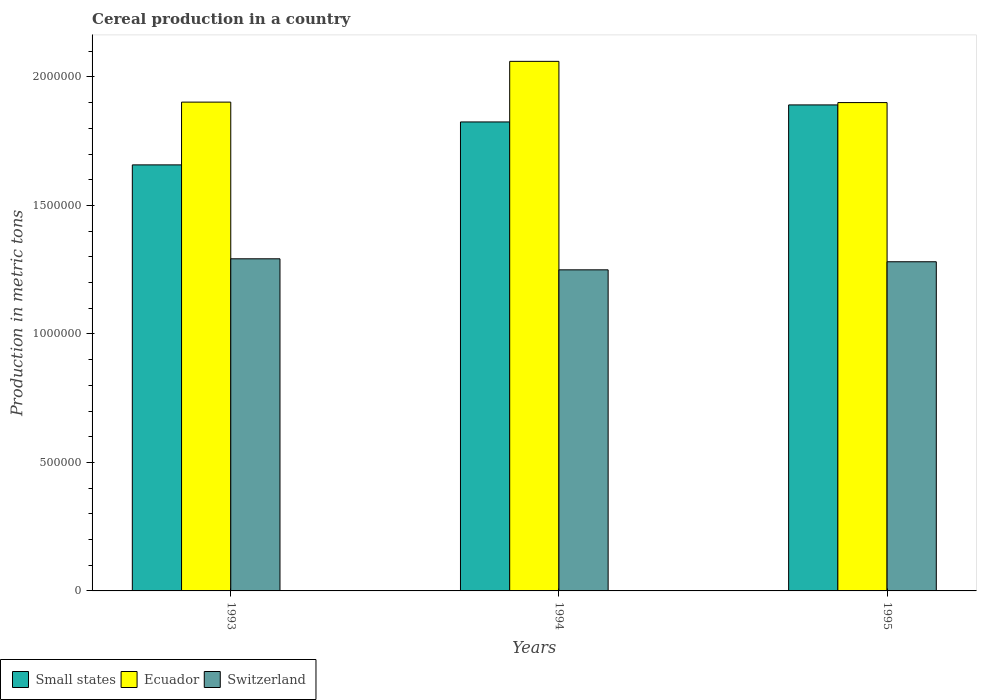How many different coloured bars are there?
Keep it short and to the point. 3. How many groups of bars are there?
Make the answer very short. 3. Are the number of bars per tick equal to the number of legend labels?
Your response must be concise. Yes. How many bars are there on the 1st tick from the left?
Offer a very short reply. 3. How many bars are there on the 2nd tick from the right?
Provide a succinct answer. 3. What is the label of the 1st group of bars from the left?
Your answer should be compact. 1993. In how many cases, is the number of bars for a given year not equal to the number of legend labels?
Keep it short and to the point. 0. What is the total cereal production in Small states in 1994?
Ensure brevity in your answer.  1.82e+06. Across all years, what is the maximum total cereal production in Switzerland?
Ensure brevity in your answer.  1.29e+06. Across all years, what is the minimum total cereal production in Ecuador?
Offer a very short reply. 1.90e+06. In which year was the total cereal production in Small states maximum?
Offer a very short reply. 1995. What is the total total cereal production in Ecuador in the graph?
Offer a terse response. 5.86e+06. What is the difference between the total cereal production in Small states in 1993 and that in 1995?
Keep it short and to the point. -2.33e+05. What is the difference between the total cereal production in Switzerland in 1993 and the total cereal production in Small states in 1994?
Your answer should be compact. -5.33e+05. What is the average total cereal production in Switzerland per year?
Ensure brevity in your answer.  1.27e+06. In the year 1993, what is the difference between the total cereal production in Switzerland and total cereal production in Small states?
Provide a succinct answer. -3.65e+05. What is the ratio of the total cereal production in Ecuador in 1993 to that in 1994?
Give a very brief answer. 0.92. What is the difference between the highest and the second highest total cereal production in Ecuador?
Keep it short and to the point. 1.59e+05. What is the difference between the highest and the lowest total cereal production in Switzerland?
Keep it short and to the point. 4.29e+04. In how many years, is the total cereal production in Ecuador greater than the average total cereal production in Ecuador taken over all years?
Your answer should be very brief. 1. Is the sum of the total cereal production in Ecuador in 1993 and 1995 greater than the maximum total cereal production in Switzerland across all years?
Your answer should be very brief. Yes. What does the 3rd bar from the left in 1995 represents?
Offer a terse response. Switzerland. What does the 1st bar from the right in 1995 represents?
Offer a terse response. Switzerland. What is the difference between two consecutive major ticks on the Y-axis?
Give a very brief answer. 5.00e+05. Are the values on the major ticks of Y-axis written in scientific E-notation?
Offer a very short reply. No. Does the graph contain any zero values?
Make the answer very short. No. Does the graph contain grids?
Provide a succinct answer. No. Where does the legend appear in the graph?
Provide a succinct answer. Bottom left. How many legend labels are there?
Provide a succinct answer. 3. How are the legend labels stacked?
Ensure brevity in your answer.  Horizontal. What is the title of the graph?
Ensure brevity in your answer.  Cereal production in a country. Does "Lebanon" appear as one of the legend labels in the graph?
Your answer should be very brief. No. What is the label or title of the X-axis?
Your answer should be very brief. Years. What is the label or title of the Y-axis?
Your answer should be very brief. Production in metric tons. What is the Production in metric tons of Small states in 1993?
Offer a very short reply. 1.66e+06. What is the Production in metric tons of Ecuador in 1993?
Your answer should be compact. 1.90e+06. What is the Production in metric tons in Switzerland in 1993?
Your answer should be very brief. 1.29e+06. What is the Production in metric tons in Small states in 1994?
Ensure brevity in your answer.  1.82e+06. What is the Production in metric tons of Ecuador in 1994?
Offer a terse response. 2.06e+06. What is the Production in metric tons of Switzerland in 1994?
Your response must be concise. 1.25e+06. What is the Production in metric tons of Small states in 1995?
Keep it short and to the point. 1.89e+06. What is the Production in metric tons of Ecuador in 1995?
Provide a succinct answer. 1.90e+06. What is the Production in metric tons of Switzerland in 1995?
Give a very brief answer. 1.28e+06. Across all years, what is the maximum Production in metric tons in Small states?
Provide a succinct answer. 1.89e+06. Across all years, what is the maximum Production in metric tons of Ecuador?
Make the answer very short. 2.06e+06. Across all years, what is the maximum Production in metric tons of Switzerland?
Your answer should be very brief. 1.29e+06. Across all years, what is the minimum Production in metric tons of Small states?
Ensure brevity in your answer.  1.66e+06. Across all years, what is the minimum Production in metric tons of Ecuador?
Keep it short and to the point. 1.90e+06. Across all years, what is the minimum Production in metric tons in Switzerland?
Ensure brevity in your answer.  1.25e+06. What is the total Production in metric tons in Small states in the graph?
Give a very brief answer. 5.37e+06. What is the total Production in metric tons of Ecuador in the graph?
Make the answer very short. 5.86e+06. What is the total Production in metric tons in Switzerland in the graph?
Make the answer very short. 3.82e+06. What is the difference between the Production in metric tons in Small states in 1993 and that in 1994?
Offer a terse response. -1.67e+05. What is the difference between the Production in metric tons in Ecuador in 1993 and that in 1994?
Your answer should be compact. -1.59e+05. What is the difference between the Production in metric tons of Switzerland in 1993 and that in 1994?
Keep it short and to the point. 4.29e+04. What is the difference between the Production in metric tons in Small states in 1993 and that in 1995?
Provide a succinct answer. -2.33e+05. What is the difference between the Production in metric tons of Ecuador in 1993 and that in 1995?
Provide a short and direct response. 1831. What is the difference between the Production in metric tons of Switzerland in 1993 and that in 1995?
Offer a terse response. 1.15e+04. What is the difference between the Production in metric tons of Small states in 1994 and that in 1995?
Offer a terse response. -6.62e+04. What is the difference between the Production in metric tons in Ecuador in 1994 and that in 1995?
Provide a succinct answer. 1.60e+05. What is the difference between the Production in metric tons of Switzerland in 1994 and that in 1995?
Your answer should be very brief. -3.14e+04. What is the difference between the Production in metric tons in Small states in 1993 and the Production in metric tons in Ecuador in 1994?
Ensure brevity in your answer.  -4.03e+05. What is the difference between the Production in metric tons of Small states in 1993 and the Production in metric tons of Switzerland in 1994?
Offer a very short reply. 4.08e+05. What is the difference between the Production in metric tons in Ecuador in 1993 and the Production in metric tons in Switzerland in 1994?
Ensure brevity in your answer.  6.53e+05. What is the difference between the Production in metric tons of Small states in 1993 and the Production in metric tons of Ecuador in 1995?
Provide a succinct answer. -2.42e+05. What is the difference between the Production in metric tons in Small states in 1993 and the Production in metric tons in Switzerland in 1995?
Keep it short and to the point. 3.77e+05. What is the difference between the Production in metric tons in Ecuador in 1993 and the Production in metric tons in Switzerland in 1995?
Offer a terse response. 6.21e+05. What is the difference between the Production in metric tons in Small states in 1994 and the Production in metric tons in Ecuador in 1995?
Keep it short and to the point. -7.53e+04. What is the difference between the Production in metric tons of Small states in 1994 and the Production in metric tons of Switzerland in 1995?
Keep it short and to the point. 5.44e+05. What is the difference between the Production in metric tons in Ecuador in 1994 and the Production in metric tons in Switzerland in 1995?
Provide a short and direct response. 7.80e+05. What is the average Production in metric tons in Small states per year?
Offer a terse response. 1.79e+06. What is the average Production in metric tons of Ecuador per year?
Make the answer very short. 1.95e+06. What is the average Production in metric tons in Switzerland per year?
Make the answer very short. 1.27e+06. In the year 1993, what is the difference between the Production in metric tons in Small states and Production in metric tons in Ecuador?
Your answer should be very brief. -2.44e+05. In the year 1993, what is the difference between the Production in metric tons in Small states and Production in metric tons in Switzerland?
Offer a very short reply. 3.65e+05. In the year 1993, what is the difference between the Production in metric tons of Ecuador and Production in metric tons of Switzerland?
Offer a terse response. 6.10e+05. In the year 1994, what is the difference between the Production in metric tons of Small states and Production in metric tons of Ecuador?
Give a very brief answer. -2.36e+05. In the year 1994, what is the difference between the Production in metric tons of Small states and Production in metric tons of Switzerland?
Offer a very short reply. 5.75e+05. In the year 1994, what is the difference between the Production in metric tons in Ecuador and Production in metric tons in Switzerland?
Offer a very short reply. 8.11e+05. In the year 1995, what is the difference between the Production in metric tons of Small states and Production in metric tons of Ecuador?
Give a very brief answer. -9104. In the year 1995, what is the difference between the Production in metric tons of Small states and Production in metric tons of Switzerland?
Your answer should be compact. 6.10e+05. In the year 1995, what is the difference between the Production in metric tons of Ecuador and Production in metric tons of Switzerland?
Your answer should be very brief. 6.19e+05. What is the ratio of the Production in metric tons in Small states in 1993 to that in 1994?
Your answer should be very brief. 0.91. What is the ratio of the Production in metric tons in Ecuador in 1993 to that in 1994?
Provide a succinct answer. 0.92. What is the ratio of the Production in metric tons of Switzerland in 1993 to that in 1994?
Provide a succinct answer. 1.03. What is the ratio of the Production in metric tons of Small states in 1993 to that in 1995?
Give a very brief answer. 0.88. What is the ratio of the Production in metric tons of Switzerland in 1993 to that in 1995?
Offer a terse response. 1.01. What is the ratio of the Production in metric tons in Ecuador in 1994 to that in 1995?
Your answer should be very brief. 1.08. What is the ratio of the Production in metric tons in Switzerland in 1994 to that in 1995?
Give a very brief answer. 0.98. What is the difference between the highest and the second highest Production in metric tons of Small states?
Your answer should be very brief. 6.62e+04. What is the difference between the highest and the second highest Production in metric tons in Ecuador?
Give a very brief answer. 1.59e+05. What is the difference between the highest and the second highest Production in metric tons of Switzerland?
Offer a very short reply. 1.15e+04. What is the difference between the highest and the lowest Production in metric tons of Small states?
Keep it short and to the point. 2.33e+05. What is the difference between the highest and the lowest Production in metric tons of Ecuador?
Give a very brief answer. 1.60e+05. What is the difference between the highest and the lowest Production in metric tons in Switzerland?
Offer a very short reply. 4.29e+04. 